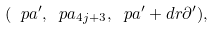Convert formula to latex. <formula><loc_0><loc_0><loc_500><loc_500>( \ p a ^ { \prime } , \ p a _ { 4 j + 3 } , \ p a ^ { \prime } + d r \partial ^ { \prime } ) ,</formula> 